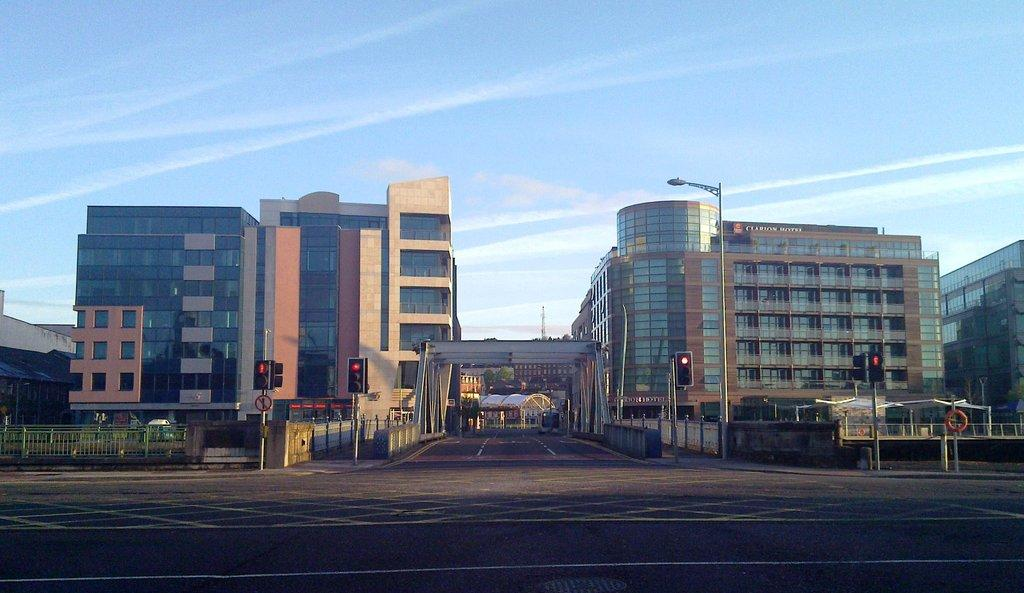What type of structures can be seen in the image? There are buildings in the image. What other natural or man-made elements can be seen in the image? There are trees, poles, traffic lights, and railings in the image. What is the primary surface visible in the image? There is a road at the bottom of the image. What is visible at the top of the image? The sky is visible at the top of the image. Can you tell me how many slices of pie are on the railings in the image? There is no pie present in the image; it features buildings, trees, poles, traffic lights, railings, a road, and the sky. What type of snakes can be seen slithering on the poles in the image? There are no snakes present in the image; it only contains the elements mentioned in the facts. 